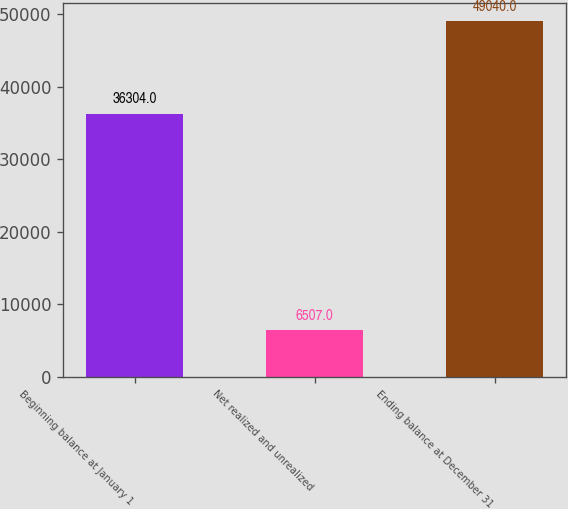Convert chart. <chart><loc_0><loc_0><loc_500><loc_500><bar_chart><fcel>Beginning balance at January 1<fcel>Net realized and unrealized<fcel>Ending balance at December 31<nl><fcel>36304<fcel>6507<fcel>49040<nl></chart> 